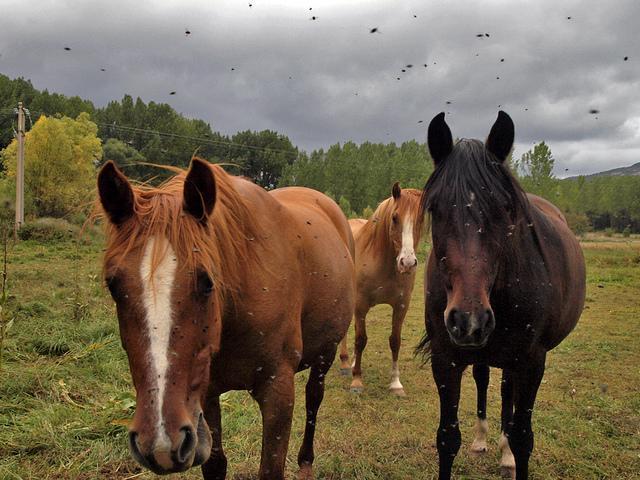How many of the horses have black manes?
Give a very brief answer. 1. How many horses?
Give a very brief answer. 3. How many horses are there?
Give a very brief answer. 3. How many bushes are to the left of the woman on the park bench?
Give a very brief answer. 0. 